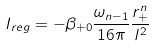Convert formula to latex. <formula><loc_0><loc_0><loc_500><loc_500>I _ { r e g } = - \beta _ { + 0 } \frac { \omega _ { n - 1 } } { 1 6 \pi } \frac { r _ { + } ^ { n } } { l ^ { 2 } }</formula> 